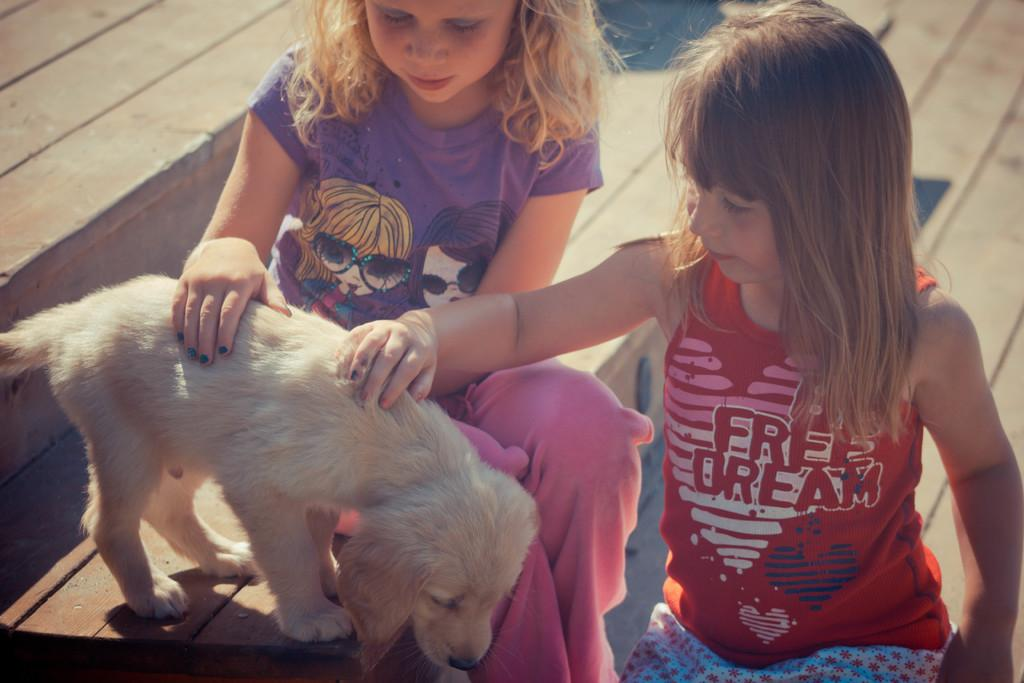How many people are in the image? There are two girls in the image. Where are the girls sitting in the image? The girls are sitting on the steps. What are the girls doing in the image? The girls are playing with a puppy. What type of plot is visible in the image? There is no plot visible in the image; it features two girls sitting on the steps and playing with a puppy. How many cars can be seen in the image? There are no cars present in the image. 